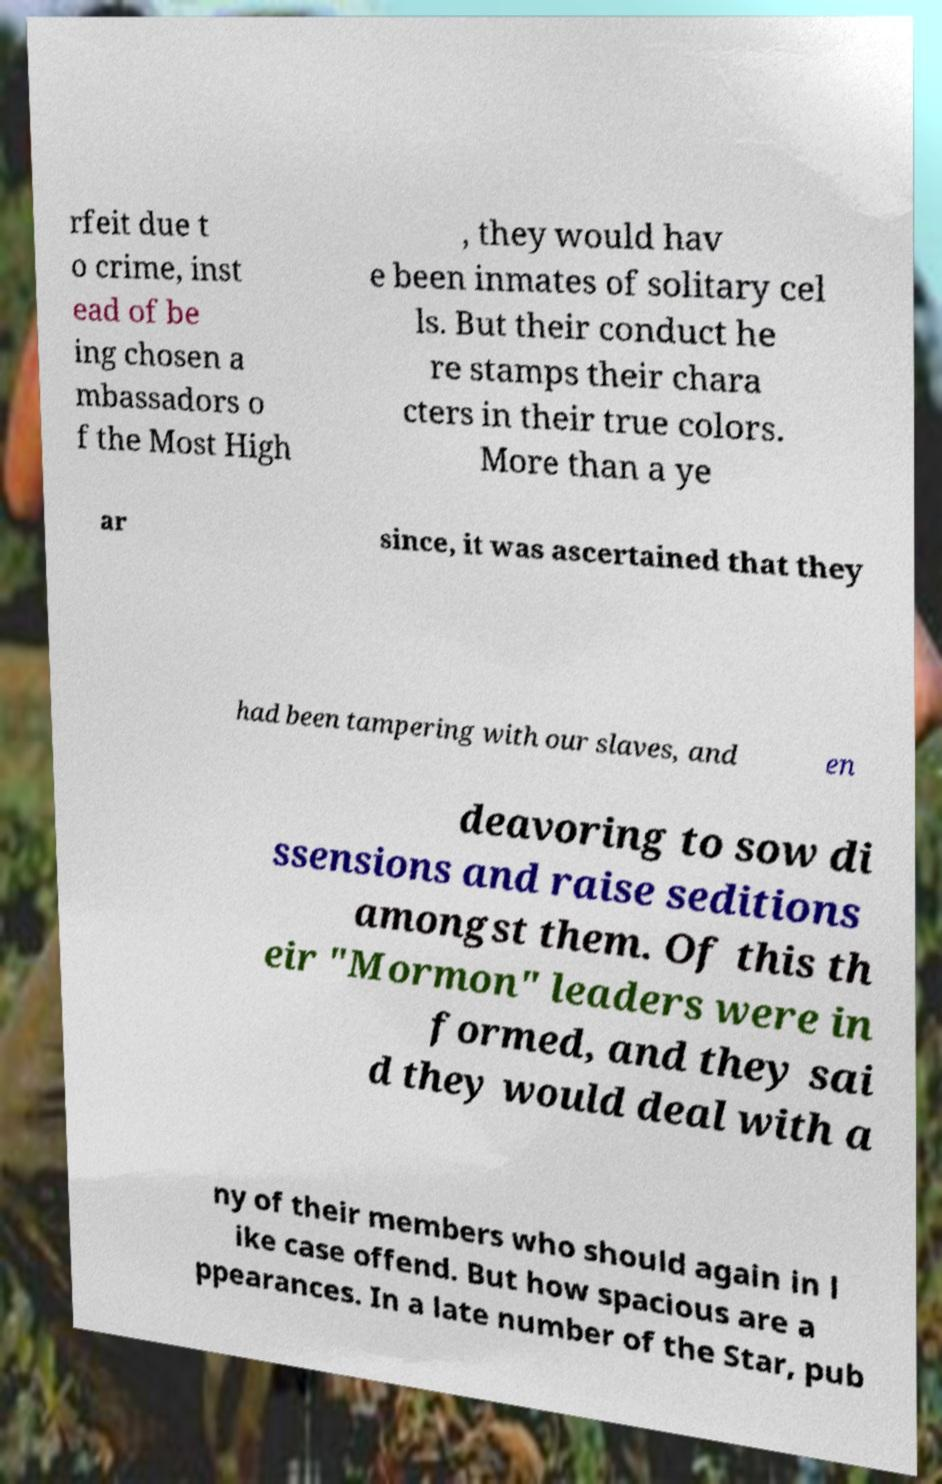Could you assist in decoding the text presented in this image and type it out clearly? rfeit due t o crime, inst ead of be ing chosen a mbassadors o f the Most High , they would hav e been inmates of solitary cel ls. But their conduct he re stamps their chara cters in their true colors. More than a ye ar since, it was ascertained that they had been tampering with our slaves, and en deavoring to sow di ssensions and raise seditions amongst them. Of this th eir "Mormon" leaders were in formed, and they sai d they would deal with a ny of their members who should again in l ike case offend. But how spacious are a ppearances. In a late number of the Star, pub 